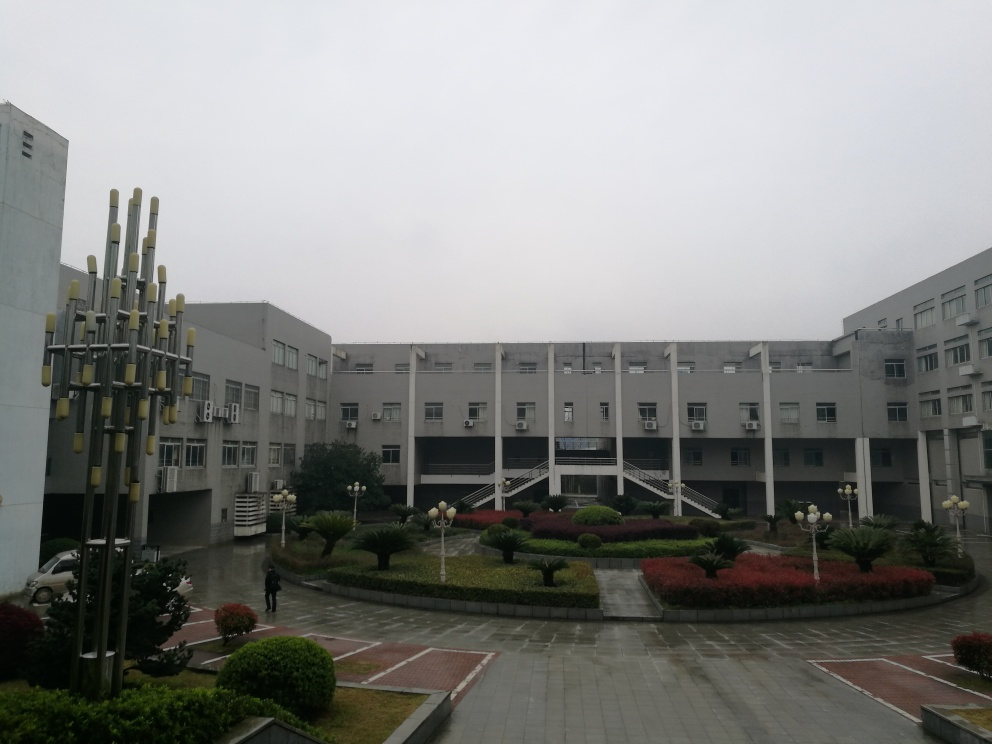What is the overall clarity of the image? The image exhibits high clarity where the architectural details, outdoor structures, and individual walking can be seen with good definition. However, considering the overcast sky contributing to a flat light and the distance from the farthest buildings, the sharpness is not exceptional, which moderately affects the perception of finer details. 